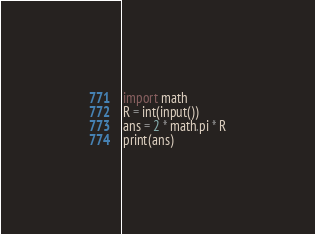Convert code to text. <code><loc_0><loc_0><loc_500><loc_500><_Python_>import math
R = int(input())
ans = 2 * math.pi * R
print(ans)</code> 